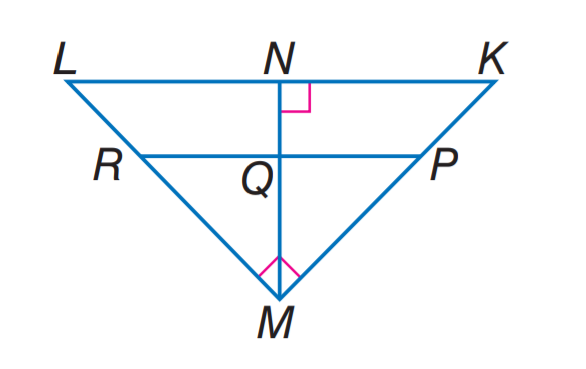Answer the mathemtical geometry problem and directly provide the correct option letter.
Question: If P R \parallel K L, K N = 9, L N = 16, and P M = 2K P, find K P.
Choices: A: 5 B: 9 C: 12 D: 15 A 